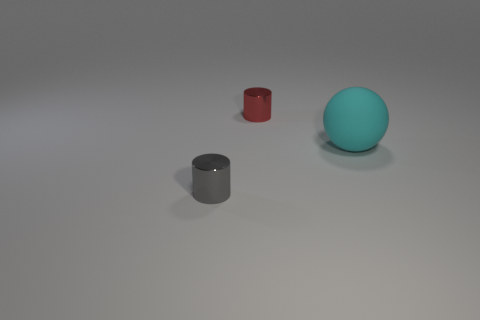What number of other things are there of the same size as the gray object?
Your response must be concise. 1. Do the thing that is left of the red metallic object and the thing that is behind the big thing have the same shape?
Your response must be concise. Yes. There is a big cyan sphere; what number of cyan rubber things are on the left side of it?
Provide a short and direct response. 0. What is the color of the tiny thing that is in front of the red cylinder?
Your answer should be very brief. Gray. The other small thing that is the same shape as the gray shiny thing is what color?
Keep it short and to the point. Red. Is the number of big things greater than the number of large brown rubber cylinders?
Offer a terse response. Yes. Is the gray object made of the same material as the red cylinder?
Provide a short and direct response. Yes. What number of cylinders have the same material as the sphere?
Make the answer very short. 0. Does the red metal thing have the same size as the cylinder in front of the cyan rubber object?
Offer a terse response. Yes. What is the color of the object that is behind the small gray shiny thing and left of the matte sphere?
Keep it short and to the point. Red. 